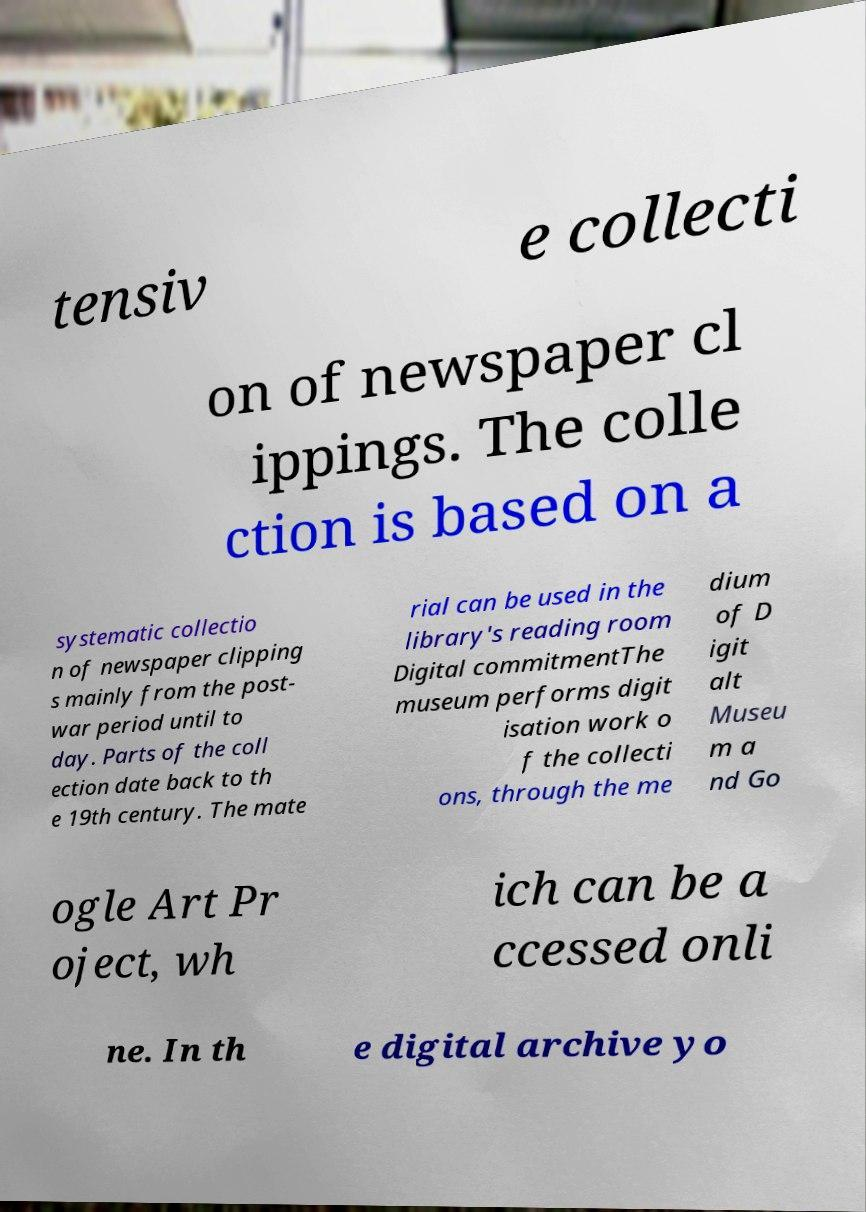What messages or text are displayed in this image? I need them in a readable, typed format. tensiv e collecti on of newspaper cl ippings. The colle ction is based on a systematic collectio n of newspaper clipping s mainly from the post- war period until to day. Parts of the coll ection date back to th e 19th century. The mate rial can be used in the library's reading room Digital commitmentThe museum performs digit isation work o f the collecti ons, through the me dium of D igit alt Museu m a nd Go ogle Art Pr oject, wh ich can be a ccessed onli ne. In th e digital archive yo 